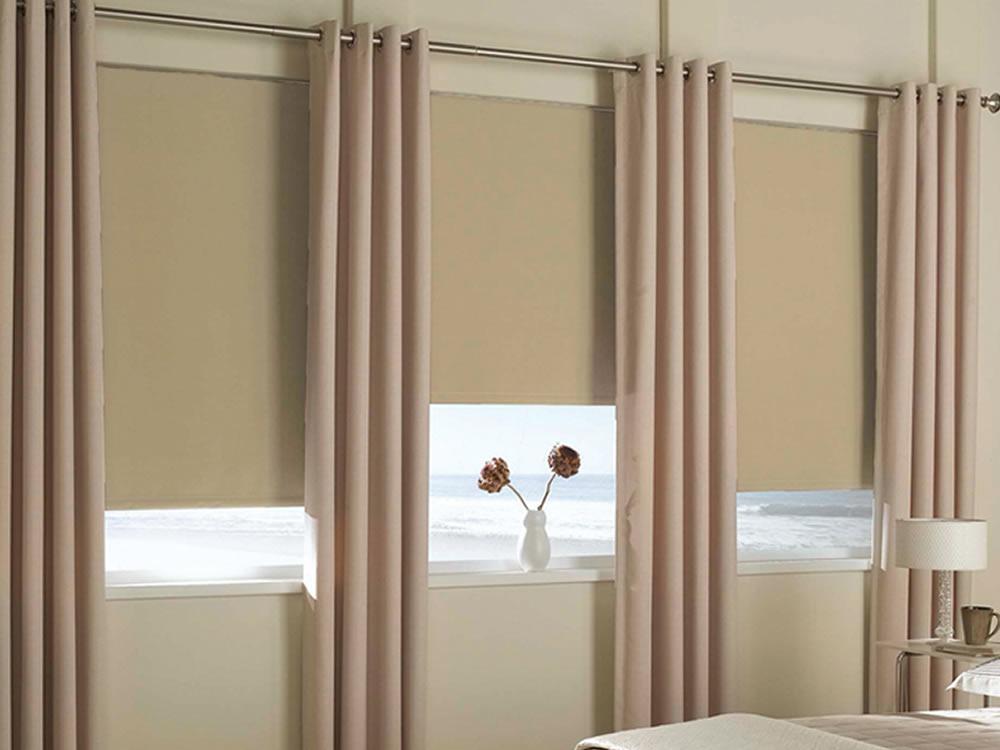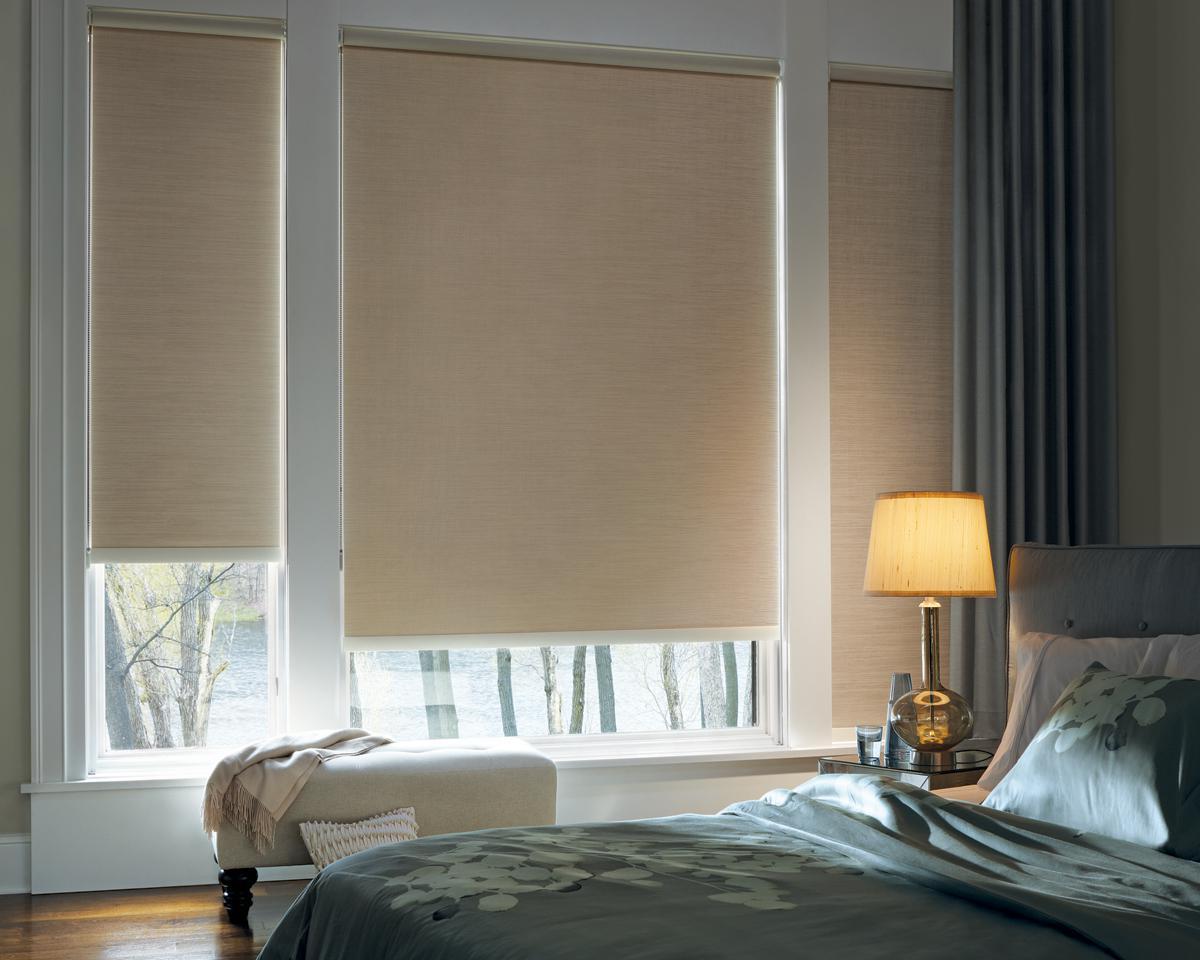The first image is the image on the left, the second image is the image on the right. Examine the images to the left and right. Is the description "There are three windows in a row that are on the same wall." accurate? Answer yes or no. Yes. 